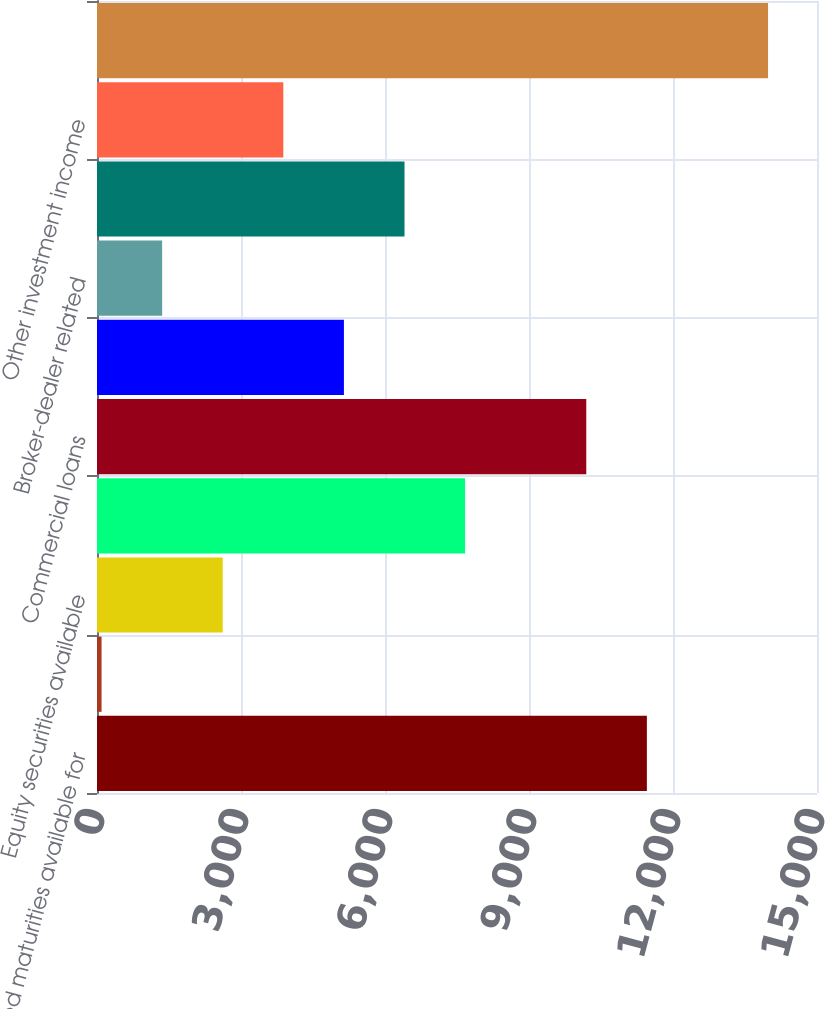Convert chart to OTSL. <chart><loc_0><loc_0><loc_500><loc_500><bar_chart><fcel>Fixed maturities available for<fcel>Fixed maturities held to<fcel>Equity securities available<fcel>Trading account assets<fcel>Commercial loans<fcel>Policy loans<fcel>Broker-dealer related<fcel>Short-term investments and<fcel>Other investment income<fcel>Gross investment income<nl><fcel>11455.7<fcel>95<fcel>2619.6<fcel>7668.8<fcel>10193.4<fcel>5144.2<fcel>1357.3<fcel>6406.5<fcel>3881.9<fcel>13980.3<nl></chart> 